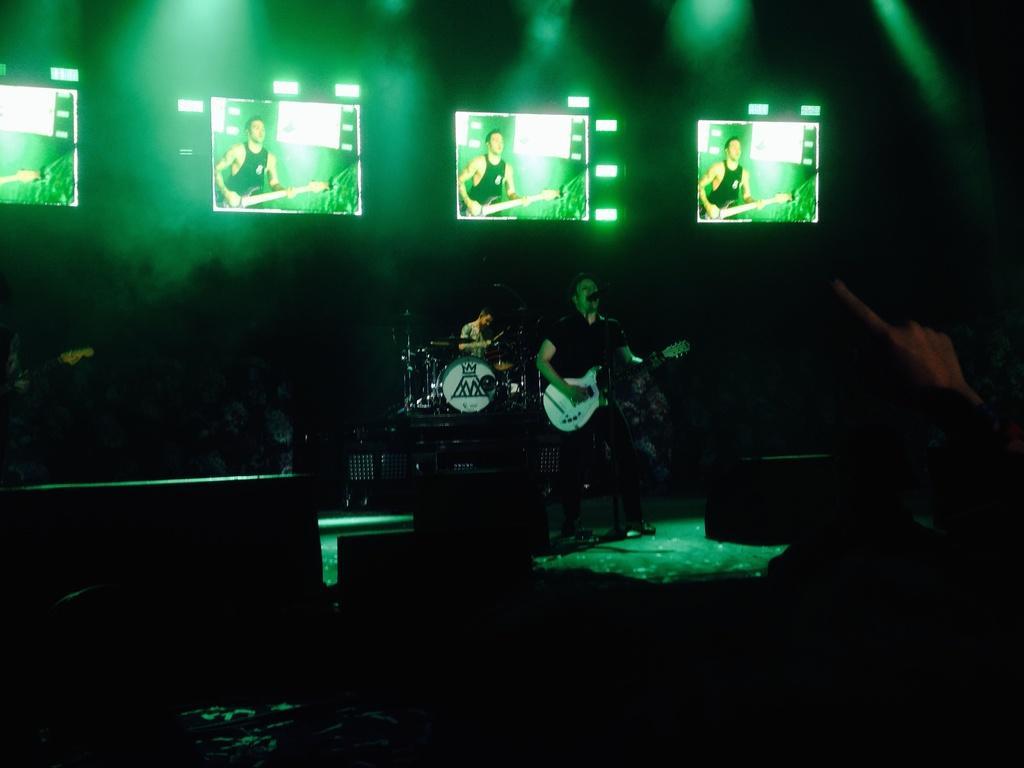In one or two sentences, can you explain what this image depicts? In this picture there is a man standing on the stage and playing guitar. Behind there is a another person playing the band. On the top there are five LED television. In the background there is a green color lights. 